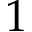<formula> <loc_0><loc_0><loc_500><loc_500>1</formula> 